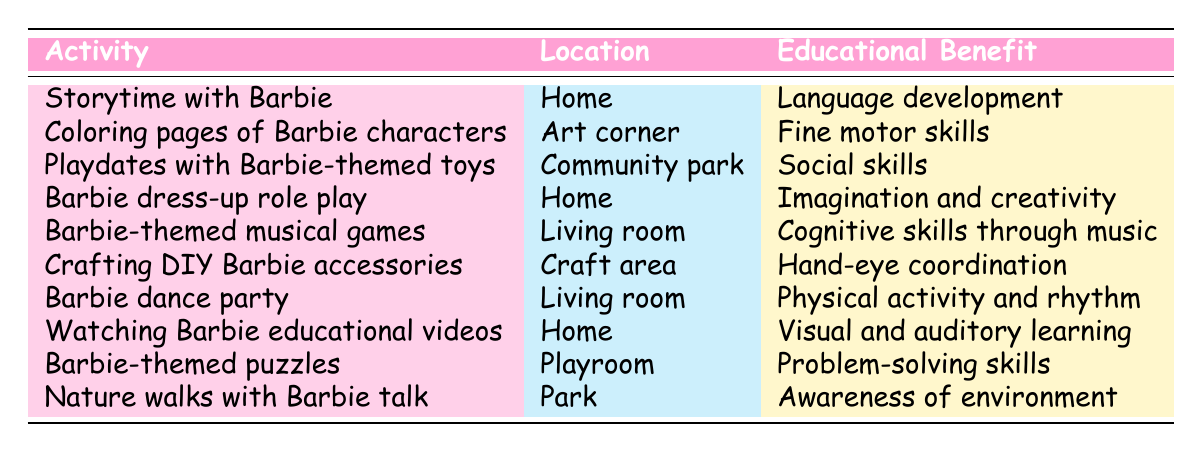What activity provides cognitive skills through music? The table lists various activities including their educational benefits. Searching for cognitive skills leads us to "Barbie-themed musical games," which directly states that it provides cognitive skills through music.
Answer: Barbie-themed musical games Where does "Coloring pages of Barbie characters" take place? In the activities listed, each includes a specific location. The row for "Coloring pages of Barbie characters" shows the location is "Art corner."
Answer: Art corner How many activities take place at home? By reviewing the table, we identify the activities listed under the location "home." These include "Storytime with Barbie," "Barbie dress-up role play," and "Watching Barbie educational videos." There are three activities in total.
Answer: 3 Are there more activities that enhance social skills or fine motor skills? To answer this, we need to count the relevant activities for each educational benefit. "Playdates with Barbie-themed toys" is the only activity emphasizing social skills, while "Coloring pages of Barbie characters" is the only fine motor skill activity. Thus, both categories have the same count: one activity each.
Answer: No, they are equal What is the educational benefit of crafting DIY Barbie accessories? Looking at the table, we find the activity "Crafting DIY Barbie accessories" and can see the corresponding educational benefit listed as "hand-eye coordination."
Answer: Hand-eye coordination Which location is associated with the most activities? By reviewing the table, we can tally the activities by location. We see that "living room" features two activities ("Barbie-themed musical games" and "Barbie dance party"), while "home" also has three activities. Therefore, "home" has the most activities compared to any other location.
Answer: Home Is the educational benefit of "Nature walks with Barbie talk" related to physical activity? The table clearly states the educational benefit of "Nature walks with Barbie talk" as "awareness of environment." Since this does not mention physical activity, the answer is no.
Answer: No What benefits do activities in the living room provide, and how many are there? The activities in the living room include "Barbie-themed musical games" and "Barbie dance party." Their educational benefits are "cognitive skills through music" and "physical activity and rhythm," respectively. There are two activities in total in the living room.
Answer: 2 activities: cognitive skills and physical activity 